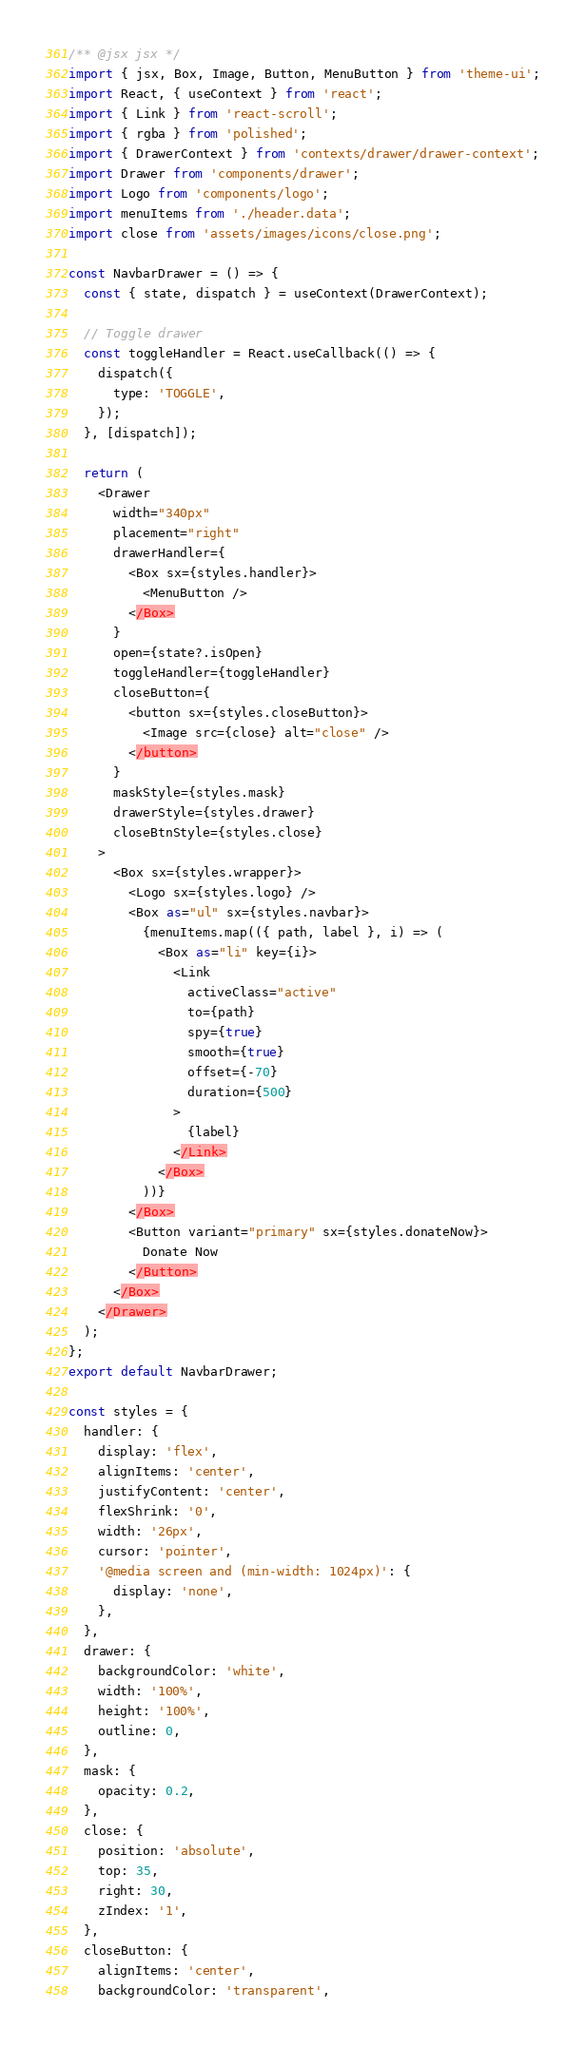Convert code to text. <code><loc_0><loc_0><loc_500><loc_500><_JavaScript_>/** @jsx jsx */
import { jsx, Box, Image, Button, MenuButton } from 'theme-ui';
import React, { useContext } from 'react';
import { Link } from 'react-scroll';
import { rgba } from 'polished';
import { DrawerContext } from 'contexts/drawer/drawer-context';
import Drawer from 'components/drawer';
import Logo from 'components/logo';
import menuItems from './header.data';
import close from 'assets/images/icons/close.png';

const NavbarDrawer = () => {
  const { state, dispatch } = useContext(DrawerContext);

  // Toggle drawer
  const toggleHandler = React.useCallback(() => {
    dispatch({
      type: 'TOGGLE',
    });
  }, [dispatch]);

  return (
    <Drawer
      width="340px"
      placement="right"
      drawerHandler={
        <Box sx={styles.handler}>
          <MenuButton />
        </Box>
      }
      open={state?.isOpen}
      toggleHandler={toggleHandler}
      closeButton={
        <button sx={styles.closeButton}>
          <Image src={close} alt="close" />
        </button>
      }
      maskStyle={styles.mask}
      drawerStyle={styles.drawer}
      closeBtnStyle={styles.close}
    >
      <Box sx={styles.wrapper}>
        <Logo sx={styles.logo} />
        <Box as="ul" sx={styles.navbar}>
          {menuItems.map(({ path, label }, i) => (
            <Box as="li" key={i}>
              <Link
                activeClass="active"
                to={path}
                spy={true}
                smooth={true}
                offset={-70}
                duration={500}
              >
                {label}
              </Link>
            </Box>
          ))}
        </Box>
        <Button variant="primary" sx={styles.donateNow}>
          Donate Now
        </Button>
      </Box>
    </Drawer>
  );
};
export default NavbarDrawer;

const styles = {
  handler: {
    display: 'flex',
    alignItems: 'center',
    justifyContent: 'center',
    flexShrink: '0',
    width: '26px',
    cursor: 'pointer',
    '@media screen and (min-width: 1024px)': {
      display: 'none',
    },
  },
  drawer: {
    backgroundColor: 'white',
    width: '100%',
    height: '100%',
    outline: 0,
  },
  mask: {
    opacity: 0.2,
  },
  close: {
    position: 'absolute',
    top: 35,
    right: 30,
    zIndex: '1',
  },
  closeButton: {
    alignItems: 'center',
    backgroundColor: 'transparent',</code> 